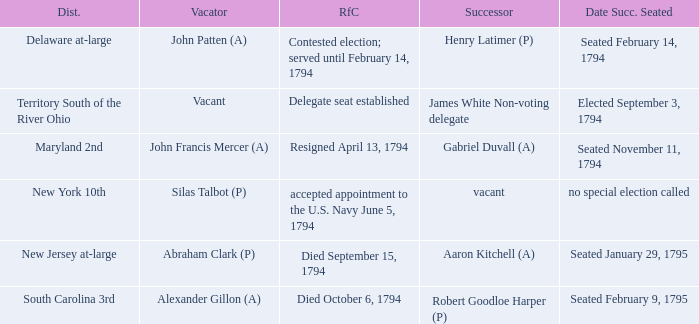Name the date successor seated for delegate seat established Elected September 3, 1794. 